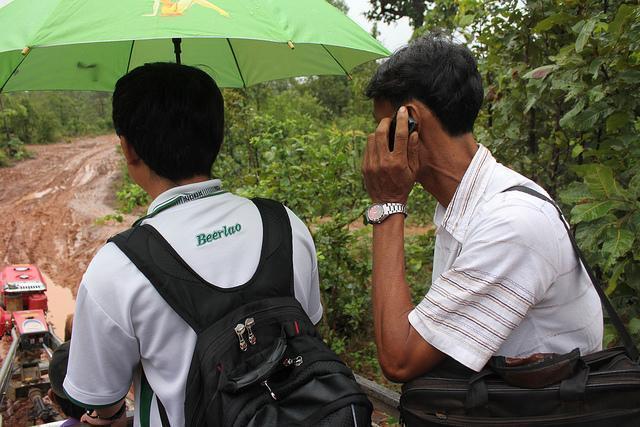How many people are visible?
Give a very brief answer. 2. 